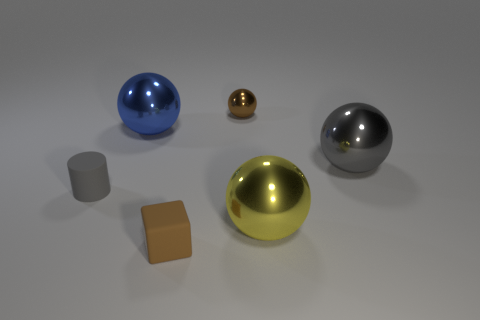There is a shiny object that is left of the brown shiny thing; is its size the same as the gray object to the right of the brown block?
Ensure brevity in your answer.  Yes. The tiny thing that is both on the right side of the small rubber cylinder and in front of the blue metal object has what shape?
Keep it short and to the point. Cube. Are there any brown blocks made of the same material as the small cylinder?
Your answer should be compact. Yes. What material is the object that is the same color as the tiny ball?
Offer a terse response. Rubber. Is the thing behind the large blue metallic sphere made of the same material as the gray object left of the small brown block?
Your answer should be very brief. No. Are there more big objects than big gray metallic objects?
Your response must be concise. Yes. What color is the matte thing that is in front of the metal object in front of the thing on the right side of the yellow thing?
Give a very brief answer. Brown. Do the shiny thing that is to the left of the small brown cube and the big sphere in front of the small matte cylinder have the same color?
Ensure brevity in your answer.  No. How many large objects are in front of the small brown matte object that is in front of the small gray matte object?
Give a very brief answer. 0. Are any brown rubber things visible?
Make the answer very short. Yes. 